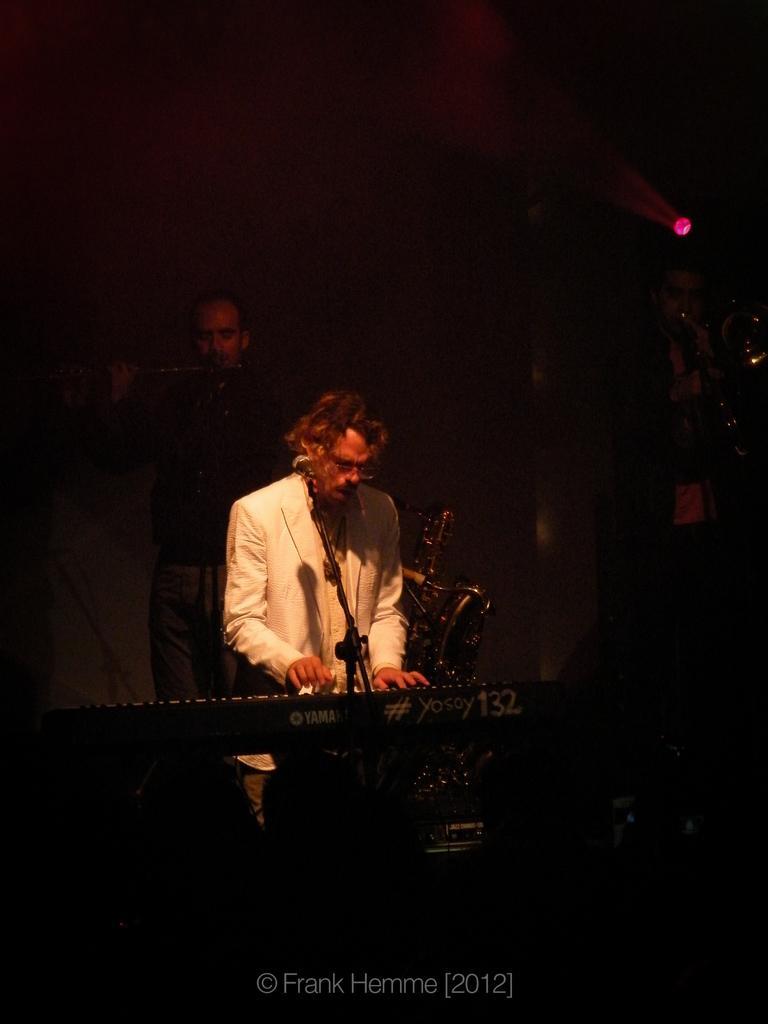How would you summarize this image in a sentence or two? This picture is dark and there is a man playing instrument and we can see microphone,behind this man we can see a man playing musical instrument. In the background we can see light. 